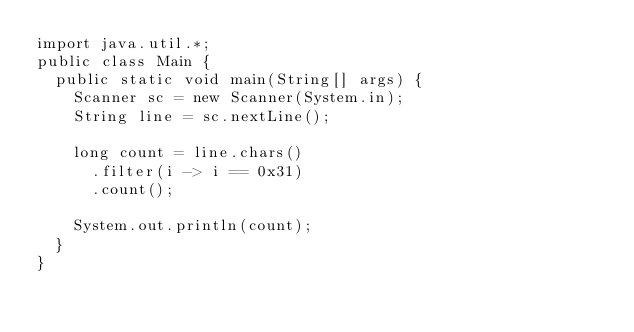Convert code to text. <code><loc_0><loc_0><loc_500><loc_500><_Java_>import java.util.*;
public class Main {
  public static void main(String[] args) {
    Scanner sc = new Scanner(System.in);
    String line = sc.nextLine();
    
    long count = line.chars()
      .filter(i -> i == 0x31)
      .count();
    
    System.out.println(count);
  }
}</code> 